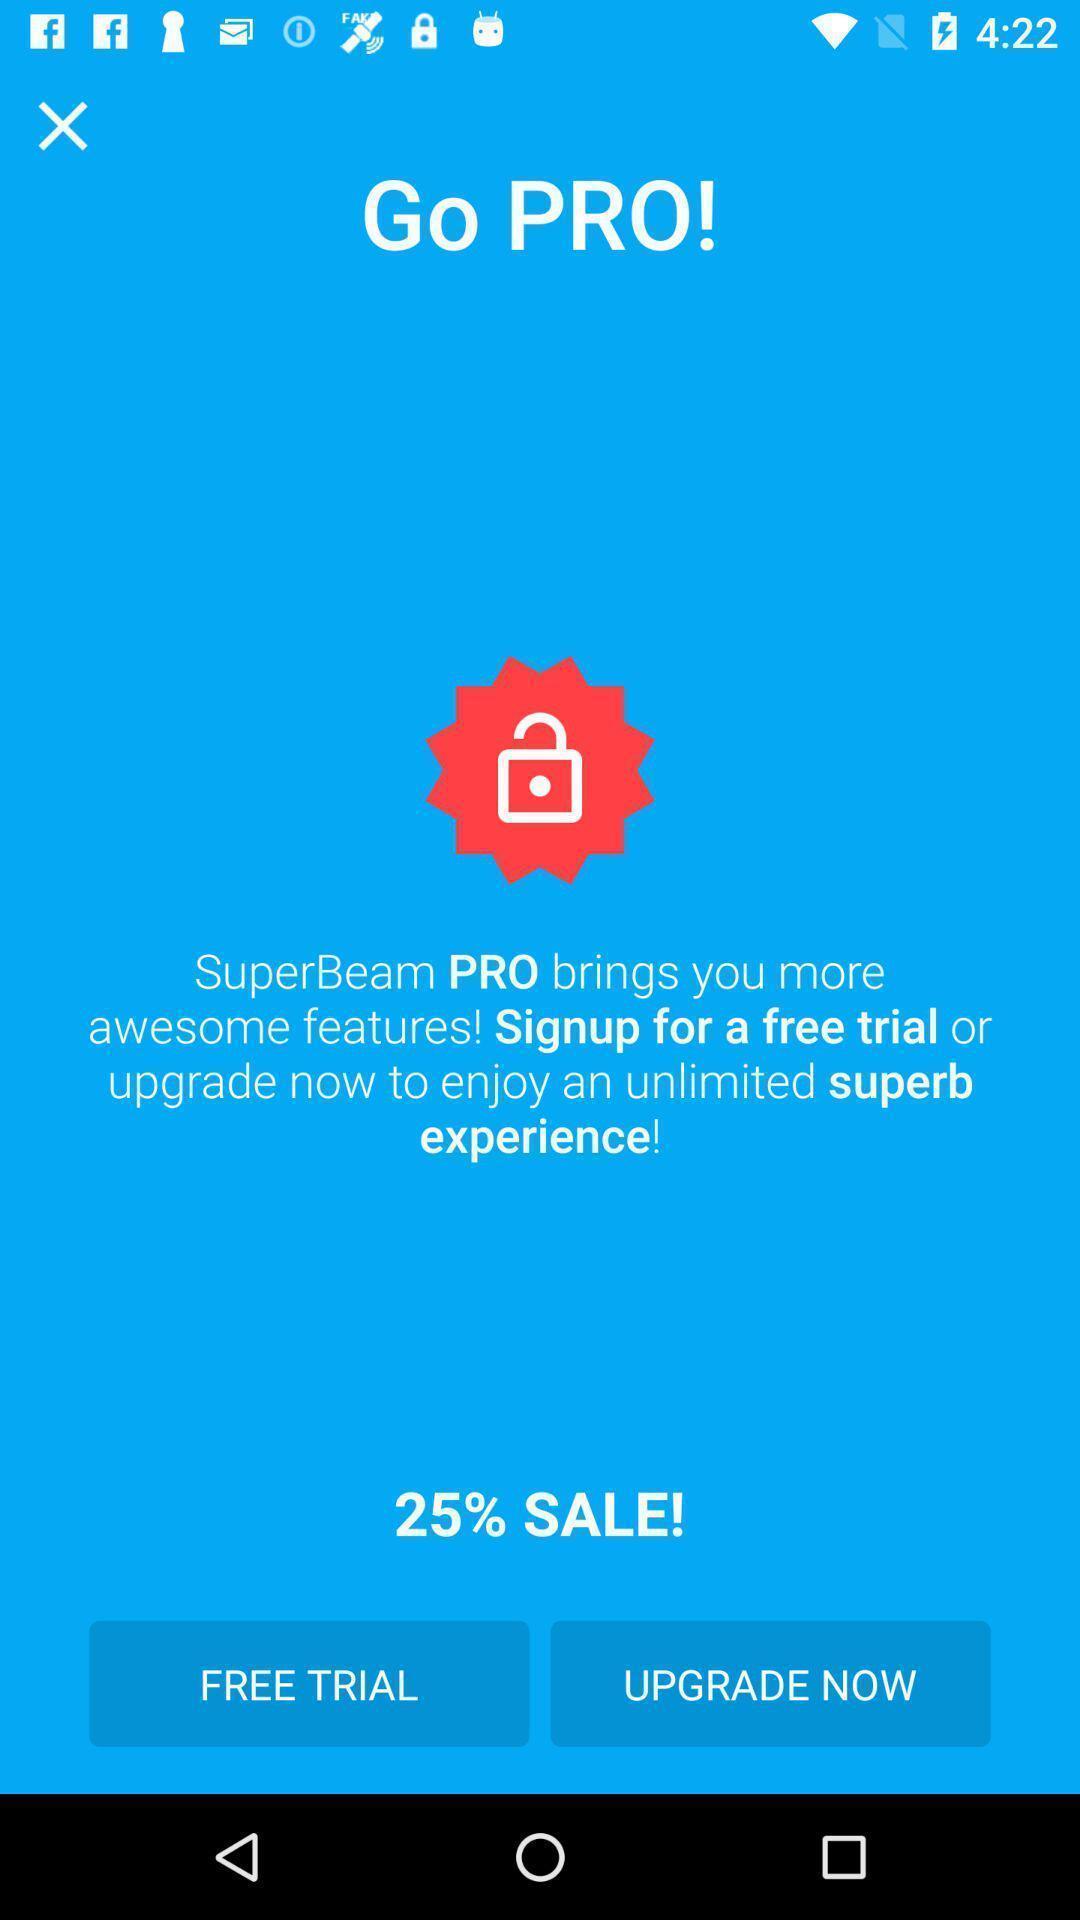Describe the key features of this screenshot. Page showing sale of a product. 